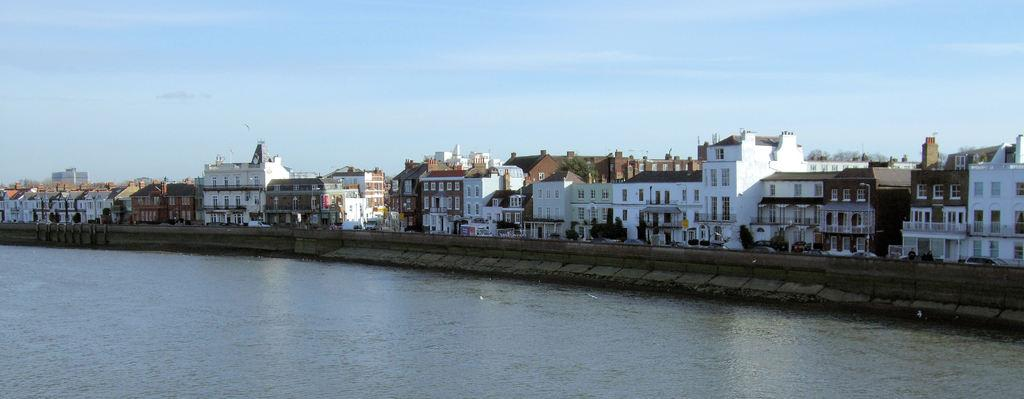What is in the foreground of the image? There is water in the foreground of the image. What can be seen in the middle of the image? There are buildings and vehicles in the middle of the image. What is visible at the top of the image? The sky is visible at the top of the image. Can you describe the sky in the image? There is a cloud in the sky. What type of banana is being used as a prop in the image? There is no banana present in the image. How many people can be seen in the image? The image does not depict any people. What is the average income of the individuals in the image? The image does not provide any information about the income of the individuals, as there are no people present. 